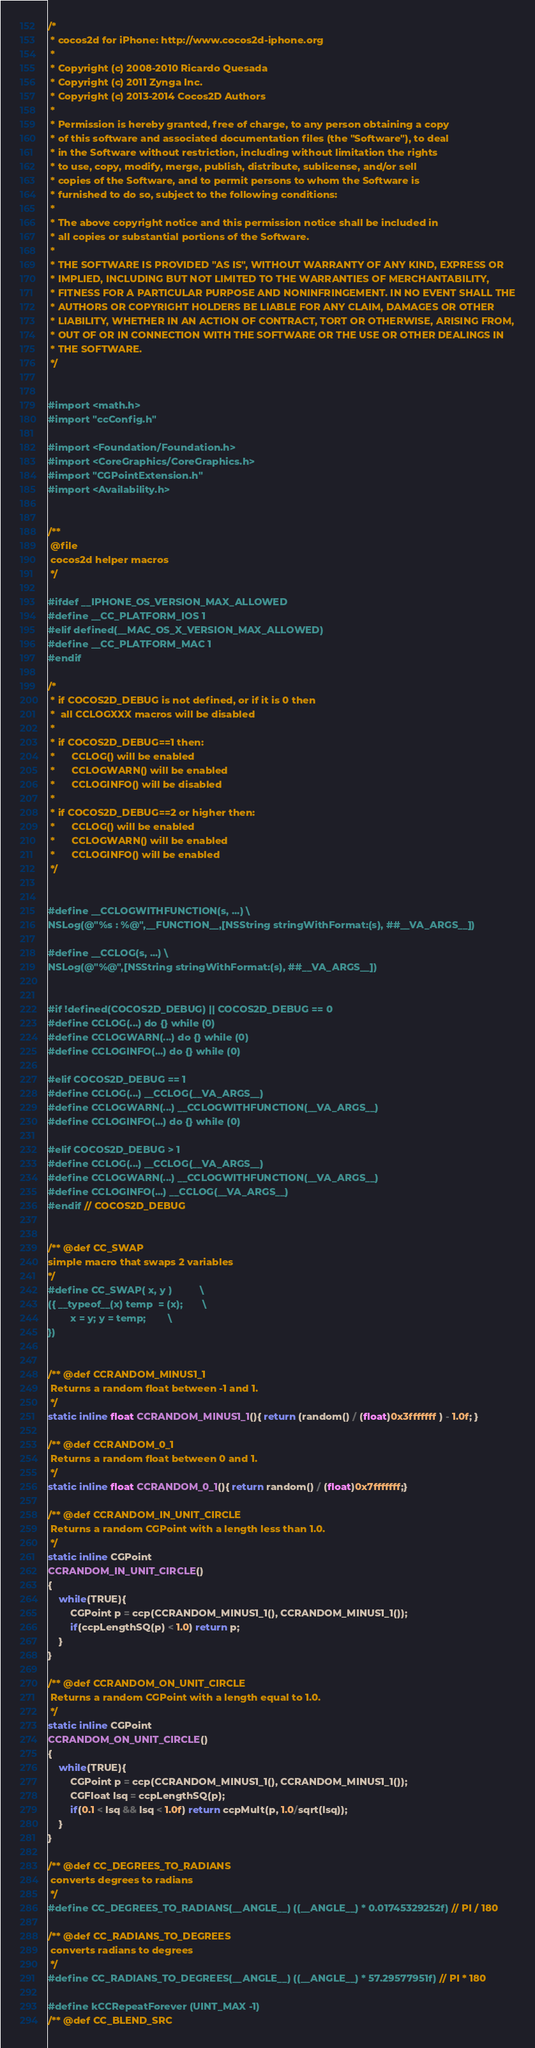<code> <loc_0><loc_0><loc_500><loc_500><_C_>/*
 * cocos2d for iPhone: http://www.cocos2d-iphone.org
 *
 * Copyright (c) 2008-2010 Ricardo Quesada
 * Copyright (c) 2011 Zynga Inc.
 * Copyright (c) 2013-2014 Cocos2D Authors
 *
 * Permission is hereby granted, free of charge, to any person obtaining a copy
 * of this software and associated documentation files (the "Software"), to deal
 * in the Software without restriction, including without limitation the rights
 * to use, copy, modify, merge, publish, distribute, sublicense, and/or sell
 * copies of the Software, and to permit persons to whom the Software is
 * furnished to do so, subject to the following conditions:
 *
 * The above copyright notice and this permission notice shall be included in
 * all copies or substantial portions of the Software.
 *
 * THE SOFTWARE IS PROVIDED "AS IS", WITHOUT WARRANTY OF ANY KIND, EXPRESS OR
 * IMPLIED, INCLUDING BUT NOT LIMITED TO THE WARRANTIES OF MERCHANTABILITY,
 * FITNESS FOR A PARTICULAR PURPOSE AND NONINFRINGEMENT. IN NO EVENT SHALL THE
 * AUTHORS OR COPYRIGHT HOLDERS BE LIABLE FOR ANY CLAIM, DAMAGES OR OTHER
 * LIABILITY, WHETHER IN AN ACTION OF CONTRACT, TORT OR OTHERWISE, ARISING FROM,
 * OUT OF OR IN CONNECTION WITH THE SOFTWARE OR THE USE OR OTHER DEALINGS IN
 * THE SOFTWARE.
 */


#import <math.h>
#import "ccConfig.h"

#import <Foundation/Foundation.h>
#import <CoreGraphics/CoreGraphics.h>
#import "CGPointExtension.h"
#import <Availability.h>


/**
 @file
 cocos2d helper macros
 */

#ifdef __IPHONE_OS_VERSION_MAX_ALLOWED
#define __CC_PLATFORM_IOS 1
#elif defined(__MAC_OS_X_VERSION_MAX_ALLOWED)
#define __CC_PLATFORM_MAC 1
#endif

/*
 * if COCOS2D_DEBUG is not defined, or if it is 0 then
 *	all CCLOGXXX macros will be disabled
 *
 * if COCOS2D_DEBUG==1 then:
 *		CCLOG() will be enabled
 *		CCLOGWARN() will be enabled
 *		CCLOGINFO()	will be disabled
 *
 * if COCOS2D_DEBUG==2 or higher then:
 *		CCLOG() will be enabled
 *		CCLOGWARN() will be enabled
 *		CCLOGINFO()	will be enabled
 */


#define __CCLOGWITHFUNCTION(s, ...) \
NSLog(@"%s : %@",__FUNCTION__,[NSString stringWithFormat:(s), ##__VA_ARGS__])

#define __CCLOG(s, ...) \
NSLog(@"%@",[NSString stringWithFormat:(s), ##__VA_ARGS__])


#if !defined(COCOS2D_DEBUG) || COCOS2D_DEBUG == 0
#define CCLOG(...) do {} while (0)
#define CCLOGWARN(...) do {} while (0)
#define CCLOGINFO(...) do {} while (0)

#elif COCOS2D_DEBUG == 1
#define CCLOG(...) __CCLOG(__VA_ARGS__)
#define CCLOGWARN(...) __CCLOGWITHFUNCTION(__VA_ARGS__)
#define CCLOGINFO(...) do {} while (0)

#elif COCOS2D_DEBUG > 1
#define CCLOG(...) __CCLOG(__VA_ARGS__)
#define CCLOGWARN(...) __CCLOGWITHFUNCTION(__VA_ARGS__)
#define CCLOGINFO(...) __CCLOG(__VA_ARGS__)
#endif // COCOS2D_DEBUG


/** @def CC_SWAP
simple macro that swaps 2 variables
*/
#define CC_SWAP( x, y )			\
({ __typeof__(x) temp  = (x);		\
		x = y; y = temp;		\
})


/** @def CCRANDOM_MINUS1_1
 Returns a random float between -1 and 1.
 */
static inline float CCRANDOM_MINUS1_1(){ return (random() / (float)0x3fffffff ) - 1.0f; }

/** @def CCRANDOM_0_1
 Returns a random float between 0 and 1.
 */
static inline float CCRANDOM_0_1(){ return random() / (float)0x7fffffff;}

/** @def CCRANDOM_IN_UNIT_CIRCLE
 Returns a random CGPoint with a length less than 1.0.
 */
static inline CGPoint
CCRANDOM_IN_UNIT_CIRCLE()
{
	while(TRUE){
		CGPoint p = ccp(CCRANDOM_MINUS1_1(), CCRANDOM_MINUS1_1());
		if(ccpLengthSQ(p) < 1.0) return p;
	}
}

/** @def CCRANDOM_ON_UNIT_CIRCLE
 Returns a random CGPoint with a length equal to 1.0.
 */
static inline CGPoint
CCRANDOM_ON_UNIT_CIRCLE()
{
	while(TRUE){
		CGPoint p = ccp(CCRANDOM_MINUS1_1(), CCRANDOM_MINUS1_1());
		CGFloat lsq = ccpLengthSQ(p);
		if(0.1 < lsq && lsq < 1.0f) return ccpMult(p, 1.0/sqrt(lsq));
	}
}

/** @def CC_DEGREES_TO_RADIANS
 converts degrees to radians
 */
#define CC_DEGREES_TO_RADIANS(__ANGLE__) ((__ANGLE__) * 0.01745329252f) // PI / 180

/** @def CC_RADIANS_TO_DEGREES
 converts radians to degrees
 */
#define CC_RADIANS_TO_DEGREES(__ANGLE__) ((__ANGLE__) * 57.29577951f) // PI * 180

#define kCCRepeatForever (UINT_MAX -1)
/** @def CC_BLEND_SRC</code> 